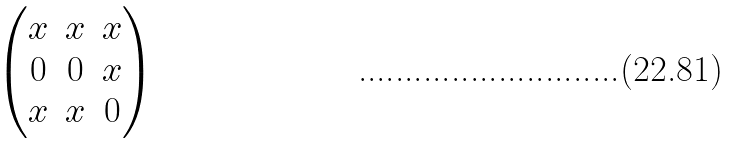Convert formula to latex. <formula><loc_0><loc_0><loc_500><loc_500>\begin{pmatrix} x & x & x \\ 0 & 0 & x \\ x & x & 0 \\ \end{pmatrix}</formula> 